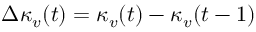<formula> <loc_0><loc_0><loc_500><loc_500>\Delta \kappa _ { v } ( t ) = \kappa _ { v } ( t ) - \kappa _ { v } ( t - 1 )</formula> 